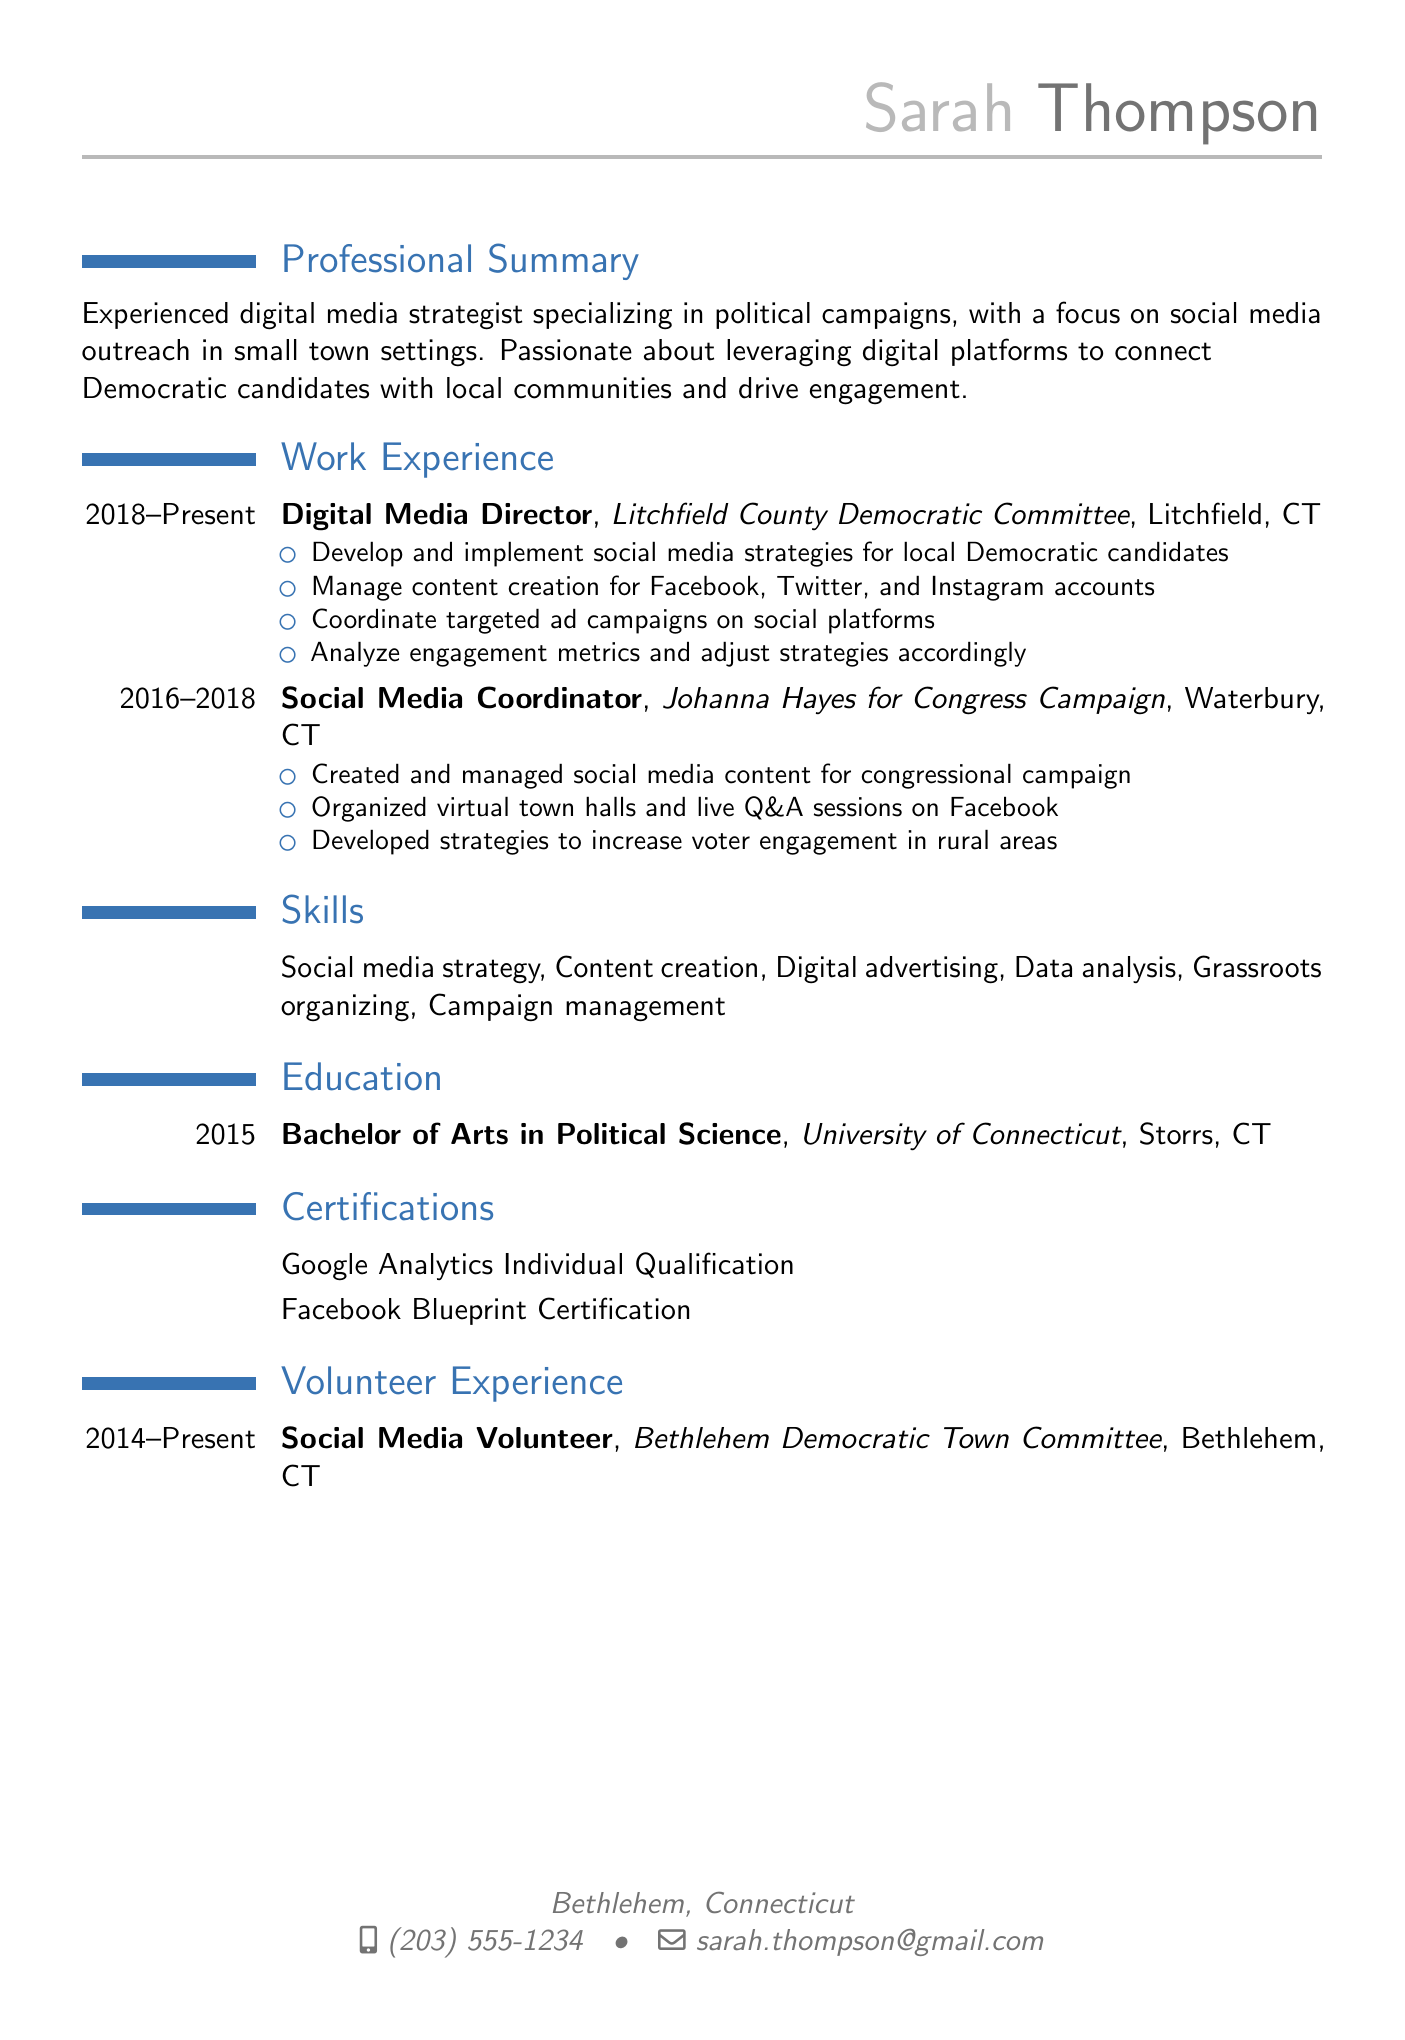What is Sarah Thompson's job title? Sarah Thompson's most recent job title as listed in the document is the last position mentioned under work experience.
Answer: Digital Media Director What organization did Sarah work for during 2016-2018? The document states her position and the corresponding organization in the work experience section for that duration.
Answer: Johanna Hayes for Congress Campaign How many years did Sarah Thompson serve as a Social Media Volunteer? The volunteer experience section specifies the duration, which starts in 2014 and continues to the present.
Answer: 9 years What is the highest degree attained by Sarah Thompson? The education section outlines her academic qualifications, specifically noting the highest degree she has completed.
Answer: Bachelor of Arts in Political Science Which certification is specifically mentioned in connection with Google? The certifying body and qualification are explicitly stated under the certifications section.
Answer: Google Analytics Individual Qualification What social media platforms does Sarah manage content creation for? The document lists the specific social media platforms in the job responsibilities under her current position.
Answer: Facebook, Twitter, and Instagram What is the focus of Sarah's professional specialization? The professional summary highlights the key area of her expertise.
Answer: Digital media strategy for political campaigns Which town committee is Sarah associated with as a volunteer? This information is clearly noted in the volunteer experience section of the CV.
Answer: Bethlehem Democratic Town Committee How many responsibilities are listed under the Digital Media Director position? The number of bullet points detailing her responsibilities in that role can be counted directly from the document.
Answer: 4 responsibilities 